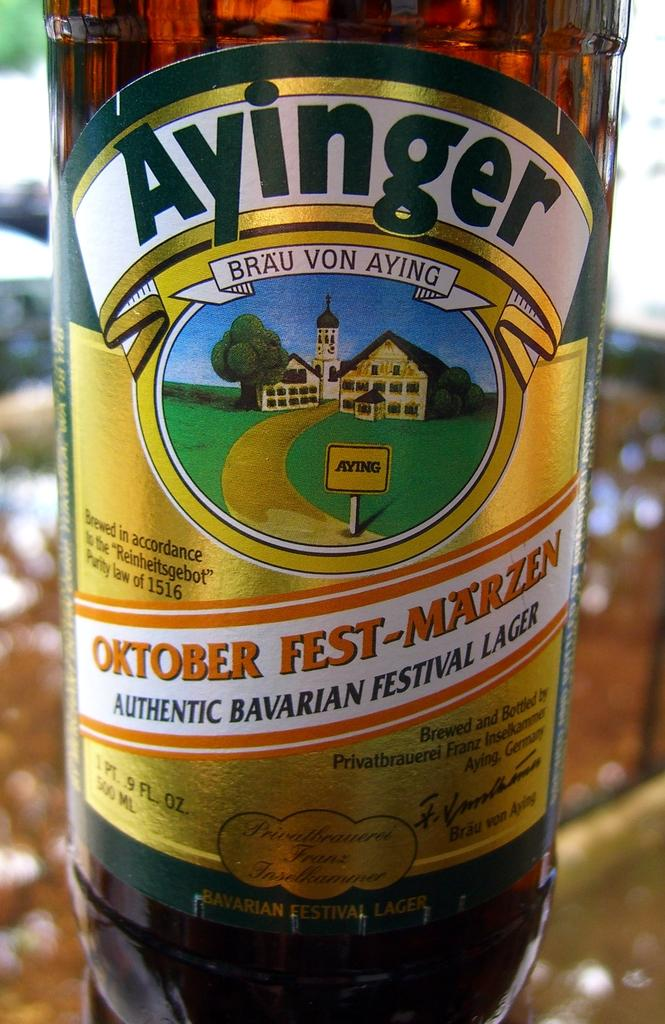<image>
Write a terse but informative summary of the picture. The bottle of brown beer shown is called Ayinger. 